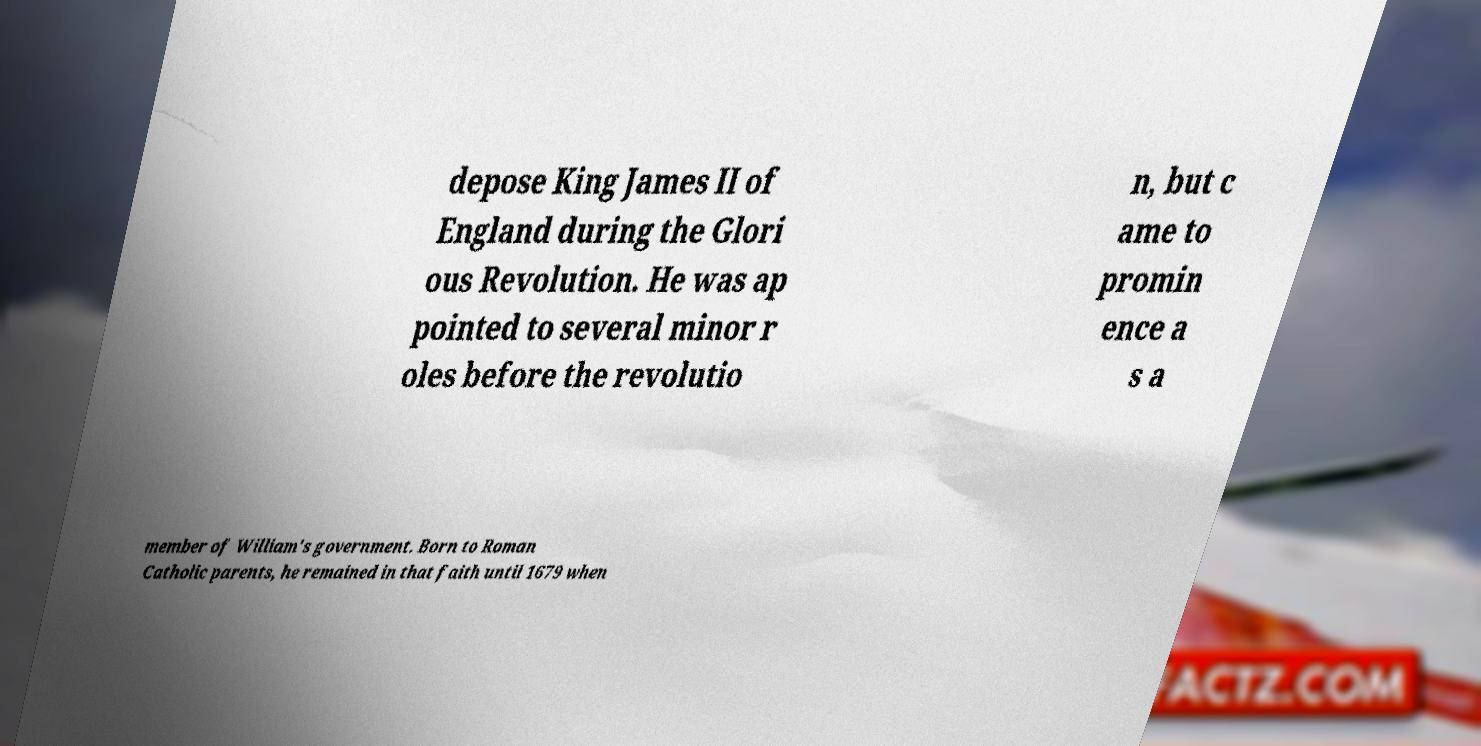What messages or text are displayed in this image? I need them in a readable, typed format. depose King James II of England during the Glori ous Revolution. He was ap pointed to several minor r oles before the revolutio n, but c ame to promin ence a s a member of William's government. Born to Roman Catholic parents, he remained in that faith until 1679 when 